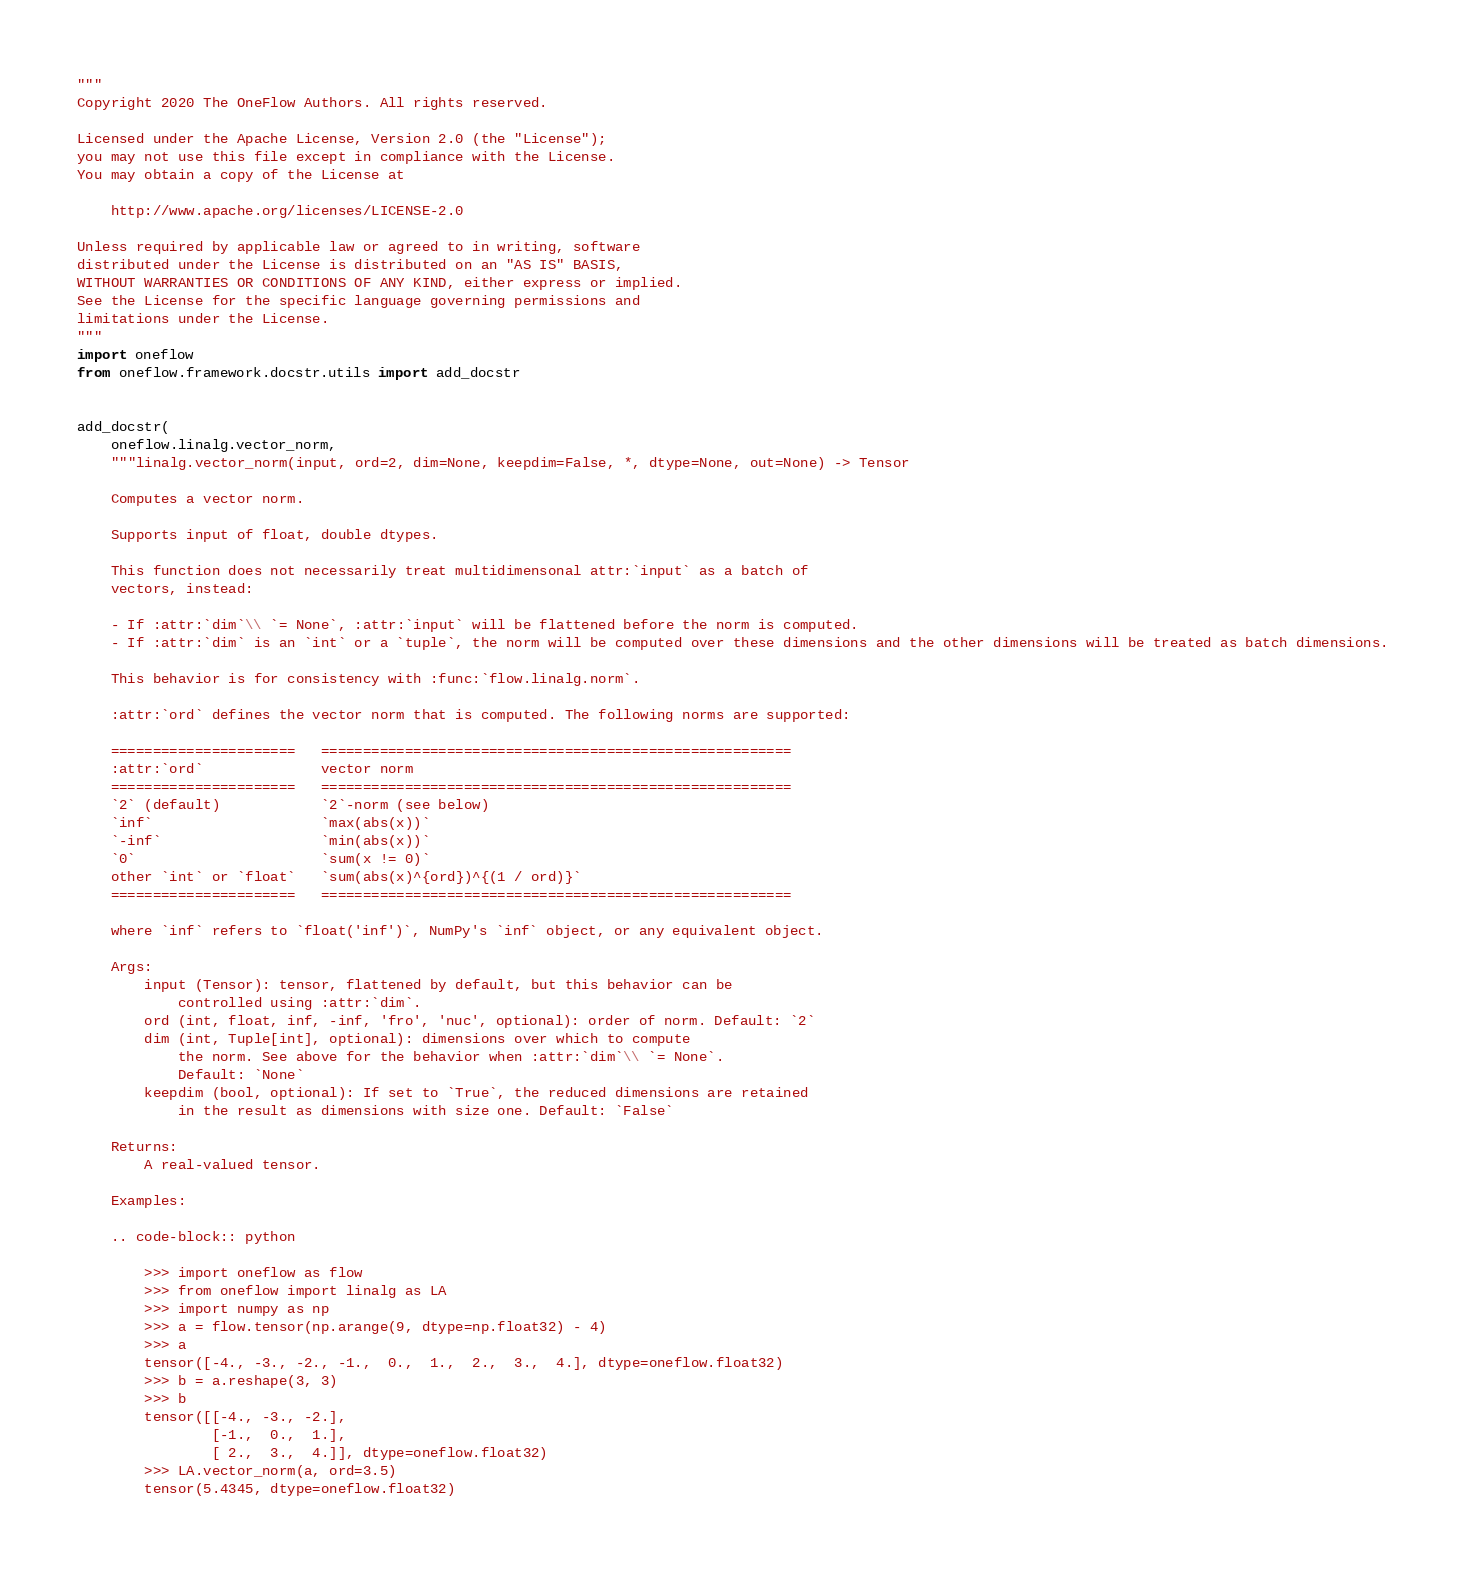<code> <loc_0><loc_0><loc_500><loc_500><_Python_>"""
Copyright 2020 The OneFlow Authors. All rights reserved.

Licensed under the Apache License, Version 2.0 (the "License");
you may not use this file except in compliance with the License.
You may obtain a copy of the License at

    http://www.apache.org/licenses/LICENSE-2.0

Unless required by applicable law or agreed to in writing, software
distributed under the License is distributed on an "AS IS" BASIS,
WITHOUT WARRANTIES OR CONDITIONS OF ANY KIND, either express or implied.
See the License for the specific language governing permissions and
limitations under the License.
"""
import oneflow
from oneflow.framework.docstr.utils import add_docstr


add_docstr(
    oneflow.linalg.vector_norm,
    """linalg.vector_norm(input, ord=2, dim=None, keepdim=False, *, dtype=None, out=None) -> Tensor

    Computes a vector norm.

    Supports input of float, double dtypes.

    This function does not necessarily treat multidimensonal attr:`input` as a batch of
    vectors, instead:

    - If :attr:`dim`\\ `= None`, :attr:`input` will be flattened before the norm is computed.
    - If :attr:`dim` is an `int` or a `tuple`, the norm will be computed over these dimensions and the other dimensions will be treated as batch dimensions.

    This behavior is for consistency with :func:`flow.linalg.norm`.

    :attr:`ord` defines the vector norm that is computed. The following norms are supported:

    ======================   ========================================================
    :attr:`ord`              vector norm
    ======================   ========================================================
    `2` (default)            `2`-norm (see below)
    `inf`                    `max(abs(x))`
    `-inf`                   `min(abs(x))`
    `0`                      `sum(x != 0)`
    other `int` or `float`   `sum(abs(x)^{ord})^{(1 / ord)}`
    ======================   ========================================================

    where `inf` refers to `float('inf')`, NumPy's `inf` object, or any equivalent object.

    Args:
        input (Tensor): tensor, flattened by default, but this behavior can be
            controlled using :attr:`dim`.
        ord (int, float, inf, -inf, 'fro', 'nuc', optional): order of norm. Default: `2`
        dim (int, Tuple[int], optional): dimensions over which to compute
            the norm. See above for the behavior when :attr:`dim`\\ `= None`.
            Default: `None`
        keepdim (bool, optional): If set to `True`, the reduced dimensions are retained
            in the result as dimensions with size one. Default: `False`

    Returns:
        A real-valued tensor.

    Examples:

    .. code-block:: python

        >>> import oneflow as flow
        >>> from oneflow import linalg as LA
        >>> import numpy as np
        >>> a = flow.tensor(np.arange(9, dtype=np.float32) - 4)
        >>> a
        tensor([-4., -3., -2., -1.,  0.,  1.,  2.,  3.,  4.], dtype=oneflow.float32)
        >>> b = a.reshape(3, 3)
        >>> b
        tensor([[-4., -3., -2.],
                [-1.,  0.,  1.],
                [ 2.,  3.,  4.]], dtype=oneflow.float32)
        >>> LA.vector_norm(a, ord=3.5)
        tensor(5.4345, dtype=oneflow.float32)</code> 